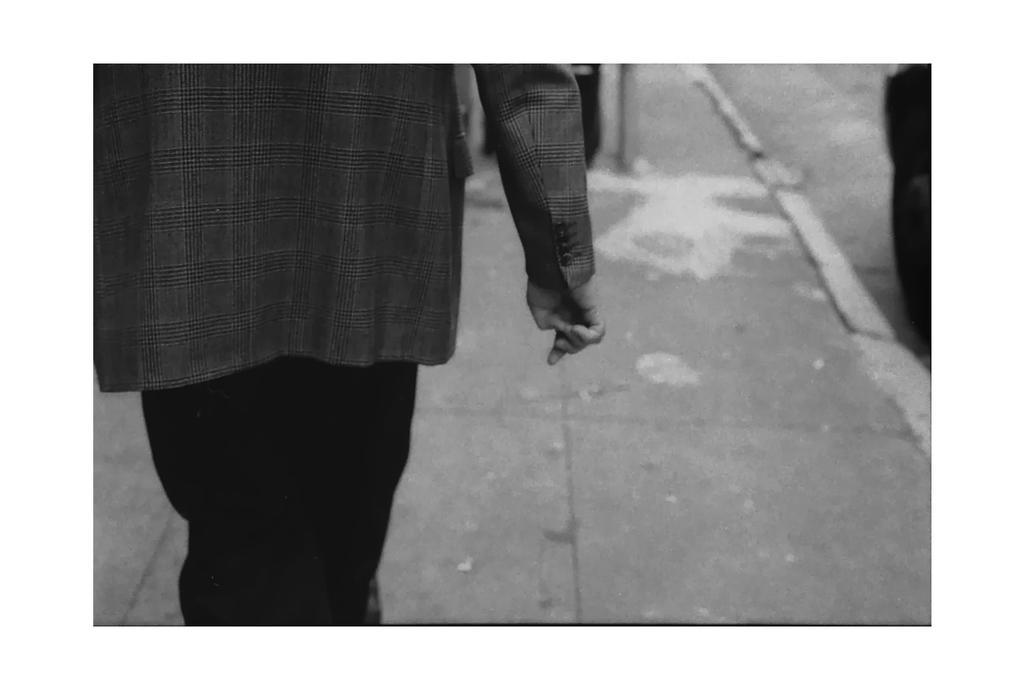Describe this image in one or two sentences. This is a black and white pic. On the left side we can see a person but head of the person is not visible. In the background we can see objects on the road and footpath. 